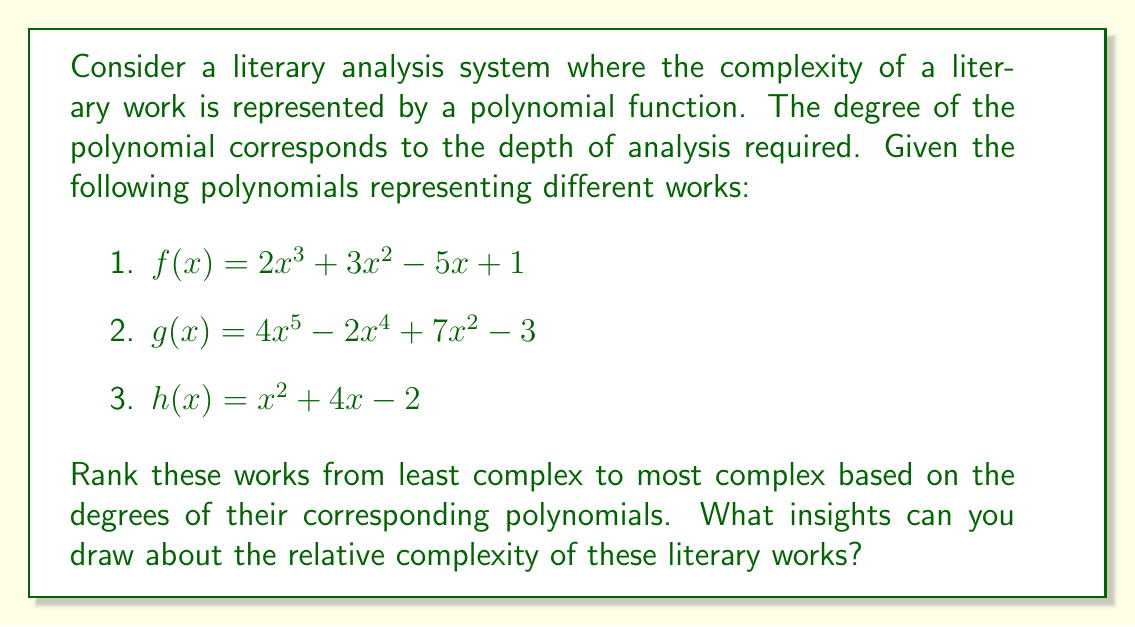Help me with this question. To solve this problem, we need to follow these steps:

1. Identify the degree of each polynomial:
   - For $f(x) = 2x^3 + 3x^2 - 5x + 1$, the highest power of x is 3, so the degree is 3.
   - For $g(x) = 4x^5 - 2x^4 + 7x^2 - 3$, the highest power of x is 5, so the degree is 5.
   - For $h(x) = x^2 + 4x - 2$, the highest power of x is 2, so the degree is 2.

2. Rank the polynomials based on their degrees from lowest to highest:
   $h(x)$ (degree 2) < $f(x)$ (degree 3) < $g(x)$ (degree 5)

3. Interpret the results in terms of literary complexity:
   - The work represented by $h(x)$ is the least complex, requiring a relatively straightforward analysis.
   - The work represented by $f(x)$ is of medium complexity, needing a more in-depth analysis.
   - The work represented by $g(x)$ is the most complex, demanding the most comprehensive and multi-layered analysis.

4. Draw insights:
   - The varying degrees suggest a range of complexity in the literary works.
   - Higher-degree polynomials (like $g(x)$) imply works with multiple layers of meaning, intricate plot structures, or complex themes that require more sophisticated analysis.
   - Lower-degree polynomials (like $h(x)$) may represent more straightforward works or those with fewer layers of interpretation.
   - The medium-complexity work ($f(x)$) might have a balance of depth and accessibility.
Answer: $h(x)$ < $f(x)$ < $g(x)$; Higher degrees indicate greater literary complexity. 